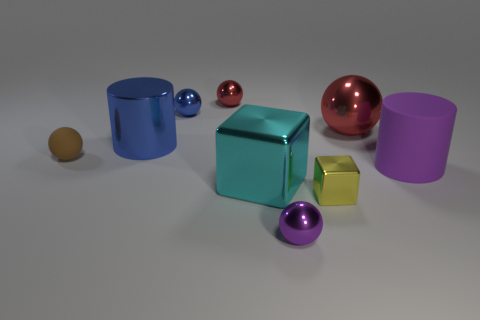There is a cylinder in front of the small brown sphere; are there any brown matte balls that are in front of it?
Offer a terse response. No. Do the big red metallic object and the blue thing that is behind the big blue thing have the same shape?
Give a very brief answer. Yes. There is a big cylinder right of the small cube; what color is it?
Your response must be concise. Purple. What size is the object left of the blue thing in front of the tiny blue metal thing?
Your answer should be very brief. Small. There is a matte thing that is left of the tiny red shiny object; is it the same shape as the small red metallic object?
Offer a very short reply. Yes. What is the material of the yellow thing that is the same shape as the big cyan thing?
Your answer should be compact. Metal. How many objects are either small blue things that are to the left of the purple matte cylinder or red spheres in front of the blue shiny sphere?
Provide a succinct answer. 2. Is the color of the small matte thing the same as the shiny cylinder that is on the left side of the big sphere?
Your answer should be compact. No. There is a purple thing that is made of the same material as the brown sphere; what is its shape?
Your answer should be very brief. Cylinder. How many small purple metallic objects are there?
Provide a succinct answer. 1. 